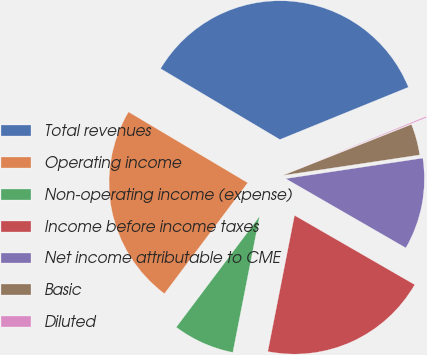Convert chart to OTSL. <chart><loc_0><loc_0><loc_500><loc_500><pie_chart><fcel>Total revenues<fcel>Operating income<fcel>Non-operating income (expense)<fcel>Income before income taxes<fcel>Net income attributable to CME<fcel>Basic<fcel>Diluted<nl><fcel>35.31%<fcel>23.28%<fcel>7.17%<fcel>19.76%<fcel>10.69%<fcel>3.65%<fcel>0.14%<nl></chart> 